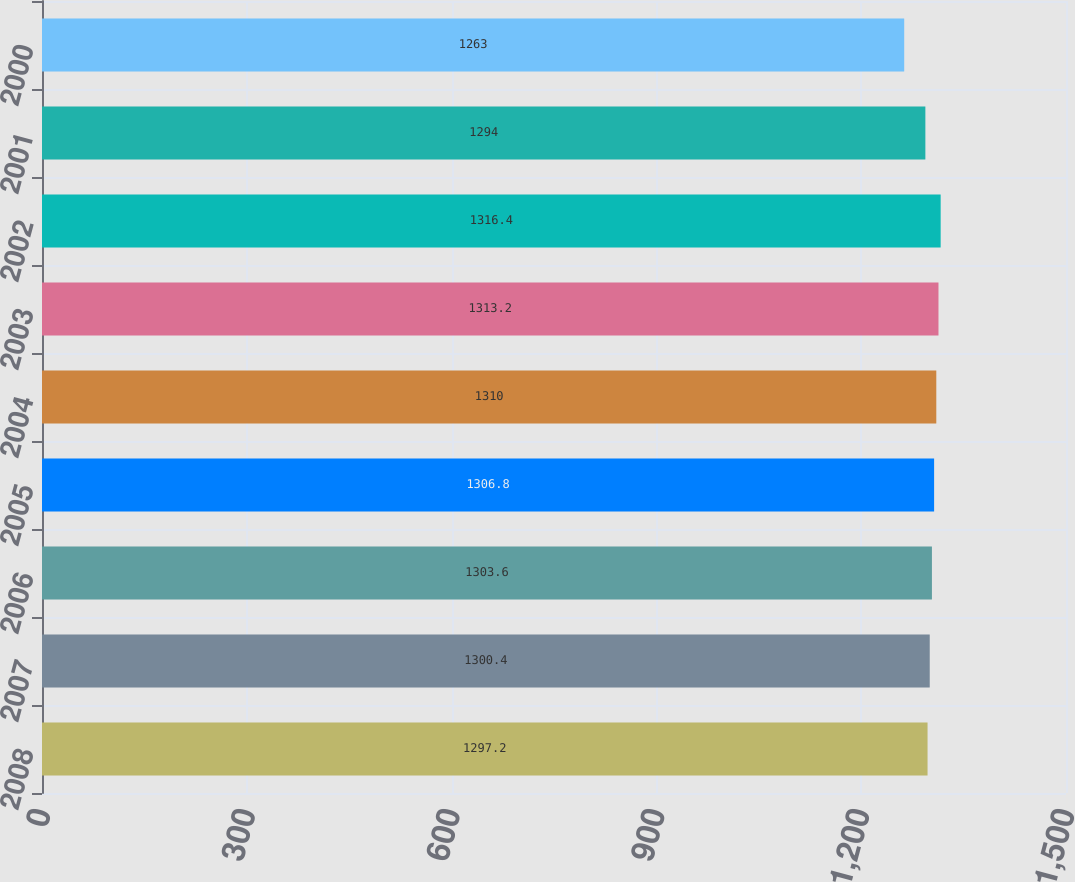Convert chart. <chart><loc_0><loc_0><loc_500><loc_500><bar_chart><fcel>2008<fcel>2007<fcel>2006<fcel>2005<fcel>2004<fcel>2003<fcel>2002<fcel>2001<fcel>2000<nl><fcel>1297.2<fcel>1300.4<fcel>1303.6<fcel>1306.8<fcel>1310<fcel>1313.2<fcel>1316.4<fcel>1294<fcel>1263<nl></chart> 